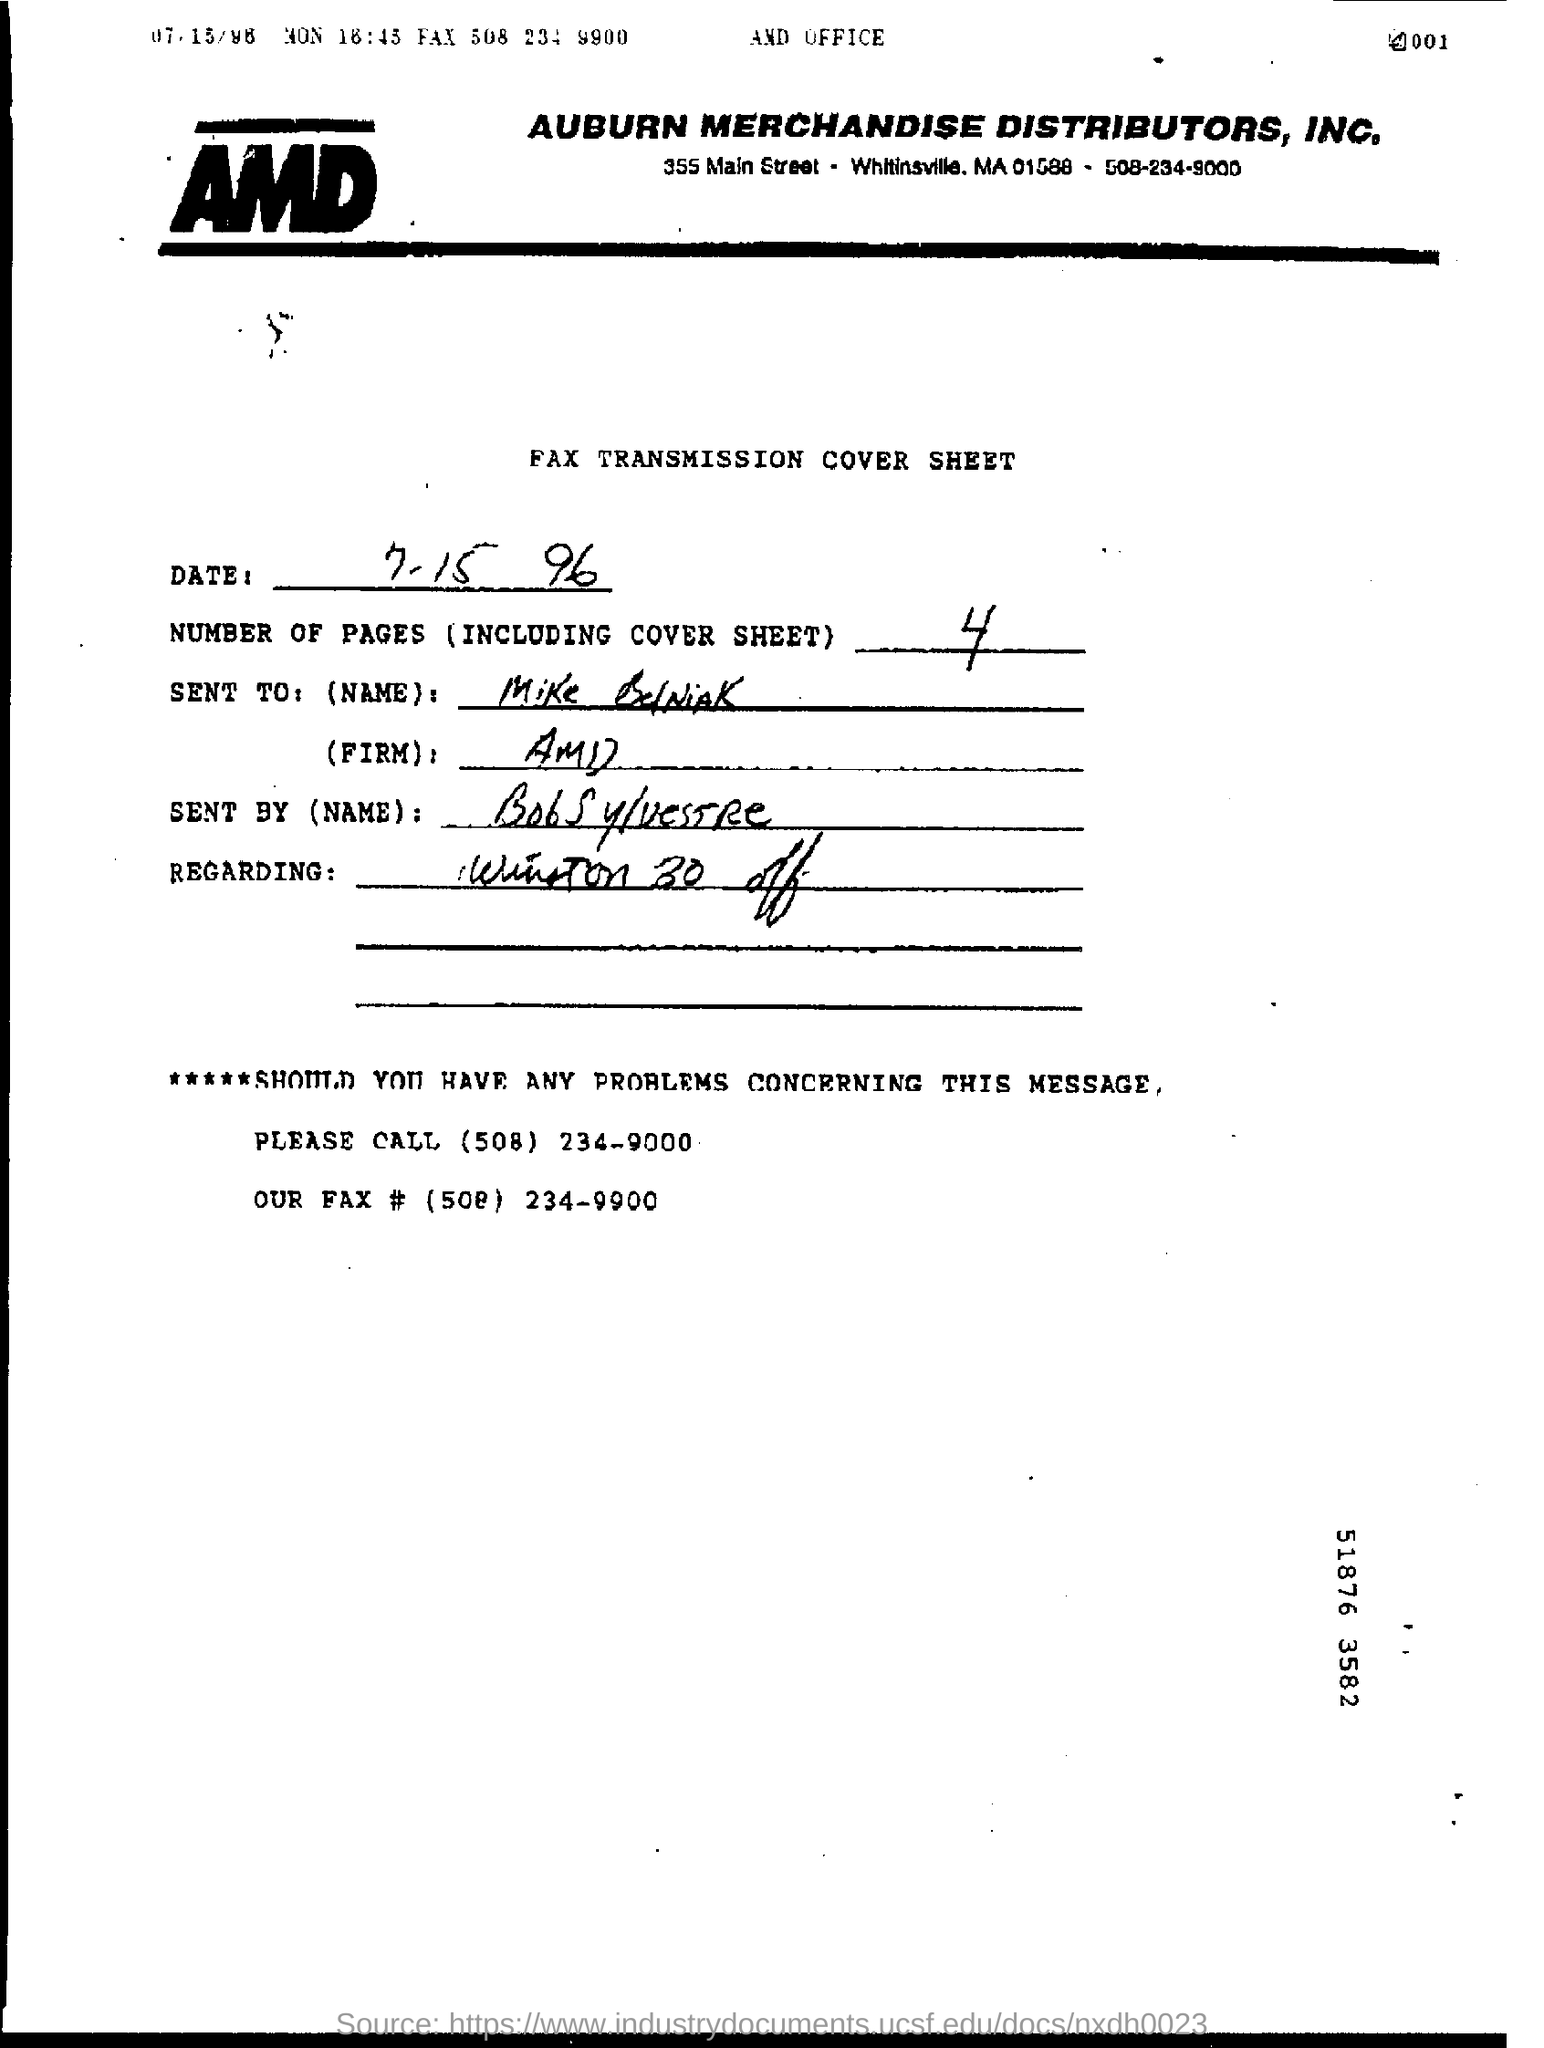Which company's name is at the top of the page?
Your response must be concise. AUBURN MERCHANDISE DISTRIBUTORS, INC. How many pages are there including cover sheet?
Keep it short and to the point. 4. When is the fax transmission cover sheet dated?
Give a very brief answer. 7-15 96. To whom is the fax addressed?
Your answer should be compact. Mike BelNiAK. Which number should you call in case of any problems?
Give a very brief answer. (508) 234-9000. 